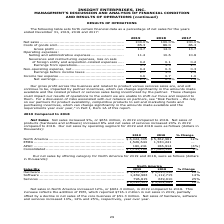According to Insight Enterprises's financial document, How much did the Net sales increased in 2019 compared to 2018? According to the financial document, $651 million. The relevant text states: "Net Sales. Net sales increased 9%, or $651 million, in 2019 compared to 2018. Net sales of products (hardware and software) increased 8% and net sales..." Also, How much did Net sales of products (hardware and software) increased in 2019 compared to 2018? According to the financial document, 8%. The relevant text states: "ales of products (hardware and software) increased 8% and net sales of services increased 20% in 2019 compared to 2018. Our net sales by operating segment..." Also, How much did net sales of services increased in 2019 compared to 2018? According to the financial document, 20%. The relevant text states: ") increased 8% and net sales of services increased 20% in 2019 compared to 2018. Our net sales by operating segment for 2019 and 2018 were as follows (doll..." Also, can you calculate: What is the change in Net sales of North America between 2018 and 2019? Based on the calculation: 6,024,305-5,362,981, the result is 661324 (in thousands). This is based on the information: "................................... $ 6,024,305 $ 5,362,981 12% EMEA ......................................................................... 1,526,644 1,530, ..........................................." The key data points involved are: 5,362,981, 6,024,305. Also, can you calculate: What is the change in Net Sales of EMEA between 2018 and 2019? Based on the calculation: 1,526,644-1,530,241, the result is -3597 (in thousands). This is based on the information: "................................................. 1,526,644 1,530,241 — APAC ......................................................................... 180,241 ....................................... 1..." The key data points involved are: 1,526,644, 1,530,241. Also, can you calculate: What is the average Net sales of North America for 2018 and 2019? To answer this question, I need to perform calculations using the financial data. The calculation is: (6,024,305+5,362,981) / 2, which equals 5693643 (in thousands). This is based on the information: "................................... $ 6,024,305 $ 5,362,981 12% EMEA ......................................................................... 1,526,644 1,530, ..........................................." The key data points involved are: 5,362,981, 6,024,305. 